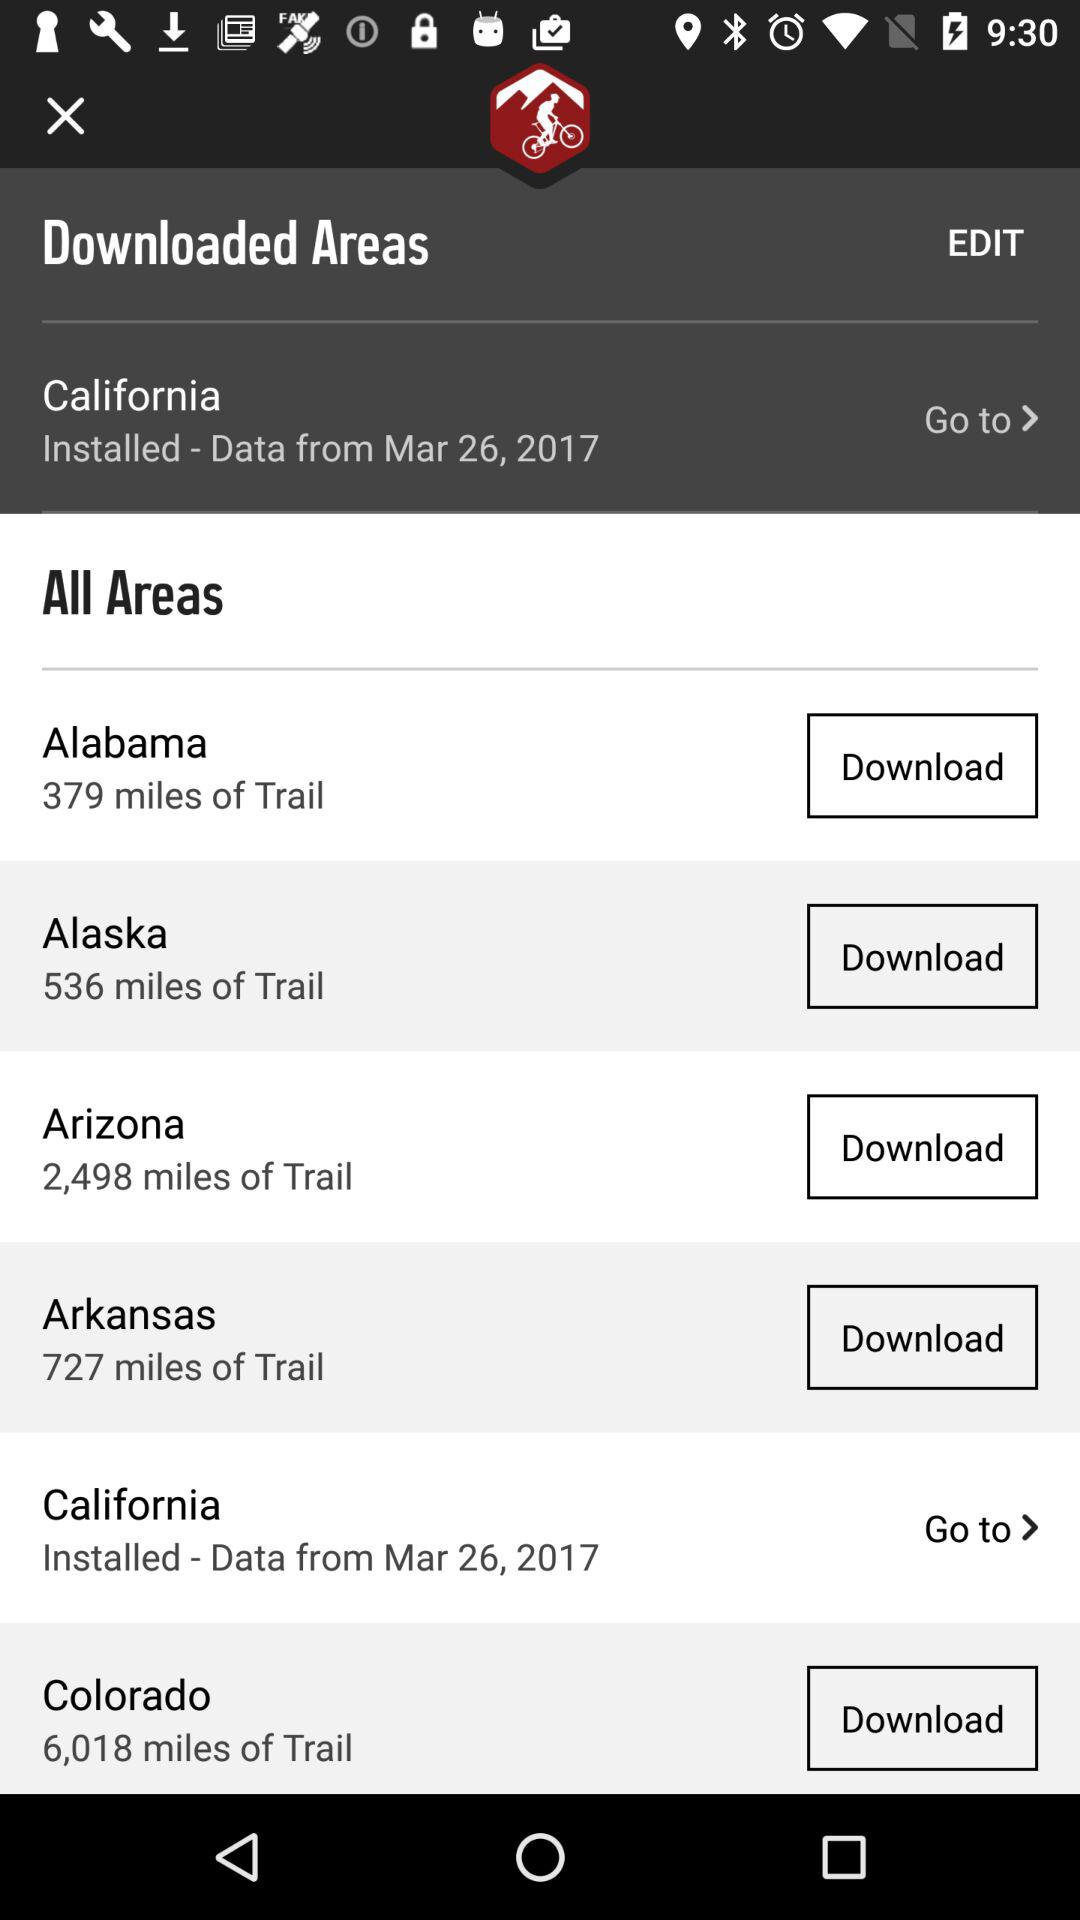What is the area given of Colorado? The given area is 6,018 miles. 